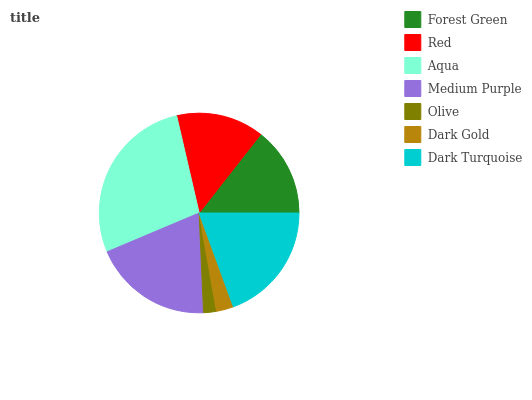Is Olive the minimum?
Answer yes or no. Yes. Is Aqua the maximum?
Answer yes or no. Yes. Is Red the minimum?
Answer yes or no. No. Is Red the maximum?
Answer yes or no. No. Is Forest Green greater than Red?
Answer yes or no. Yes. Is Red less than Forest Green?
Answer yes or no. Yes. Is Red greater than Forest Green?
Answer yes or no. No. Is Forest Green less than Red?
Answer yes or no. No. Is Forest Green the high median?
Answer yes or no. Yes. Is Forest Green the low median?
Answer yes or no. Yes. Is Dark Gold the high median?
Answer yes or no. No. Is Red the low median?
Answer yes or no. No. 